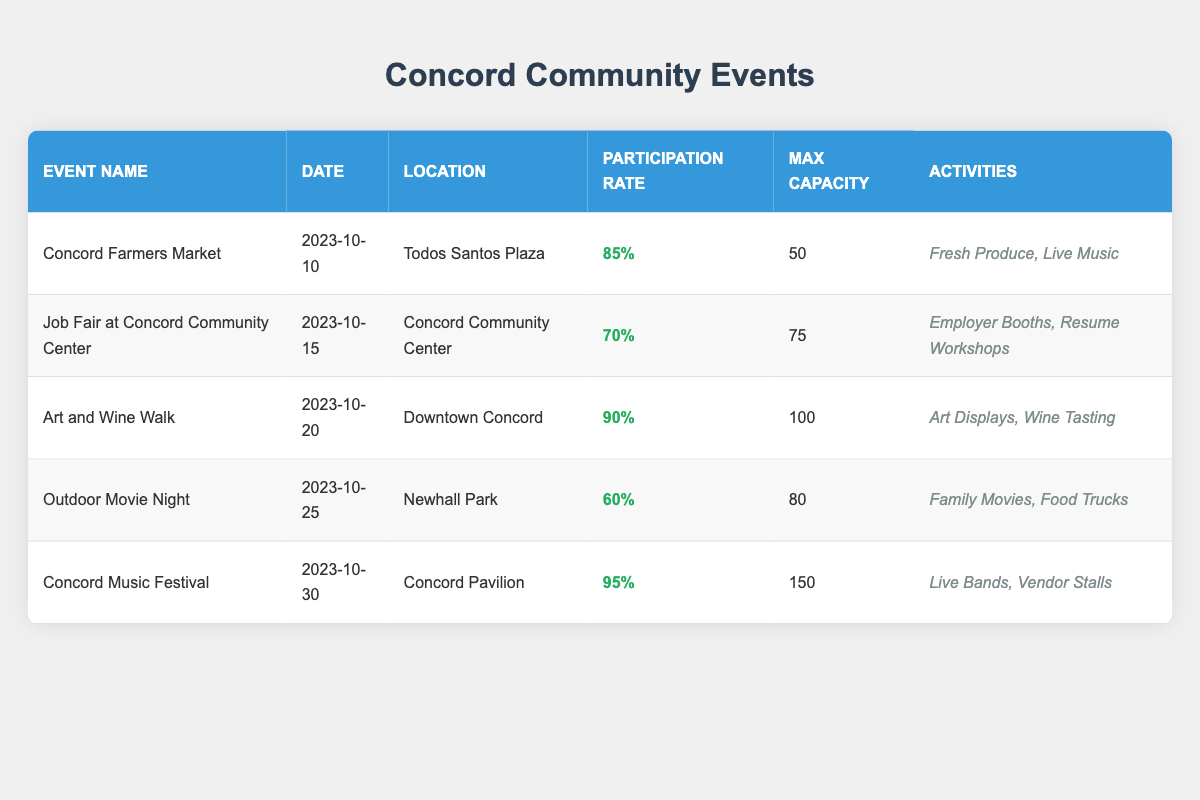What is the participation rate for the Concord Farmers Market? The Concord Farmers Market has a participation rate of 85%, as indicated in the table under the "Participation Rate" column for that specific event.
Answer: 85% Which event has the maximum capacity of 150? The Concord Music Festival has the maximum capacity of 150, which is the highest value listed under the "Max Capacity" column.
Answer: Concord Music Festival What is the average participation rate of all events listed? To find the average participation rate, sum the participation rates (85 + 70 + 90 + 60 + 95 = 400) and divide by the number of events (5). The average is 400 / 5 = 80.
Answer: 80% Did the Job Fair at Concord Community Center have a higher participation rate than the Outdoor Movie Night? The Job Fair has a participation rate of 70% and the Outdoor Movie Night has a participation rate of 60%. Since 70% is greater than 60%, the statement is true.
Answer: Yes Which event has the lowest participation rate and what is that rate? The event with the lowest participation rate is the Outdoor Movie Night, which has a participation rate of 60%. This is the minimum value found in the "Participation Rate" column when compared with all events.
Answer: 60% If the Concord Music Festival reaches its maximum capacity, how many attendees would it have? Since the Concord Music Festival has a maximum capacity of 150, if it reaches its maximum capacity, it would have 150 attendees, as stated directly in the "Max Capacity" column.
Answer: 150 What activities are offered at the Art and Wine Walk? The table lists the activities for the Art and Wine Walk as "Art Displays" and "Wine Tasting," which are referenced in the "Activities" column.
Answer: Art Displays, Wine Tasting Is there an event scheduled for October 25, 2023? Yes, the Outdoor Movie Night is scheduled for October 25, 2023, as shown in the "Date" column.
Answer: Yes How many events have a participation rate above 80%? There are three events with participation rates above 80%: the Concord Farmers Market (85%), the Art and Wine Walk (90%), and the Concord Music Festival (95%). This requires checking each event’s participation rate in the table.
Answer: 3 